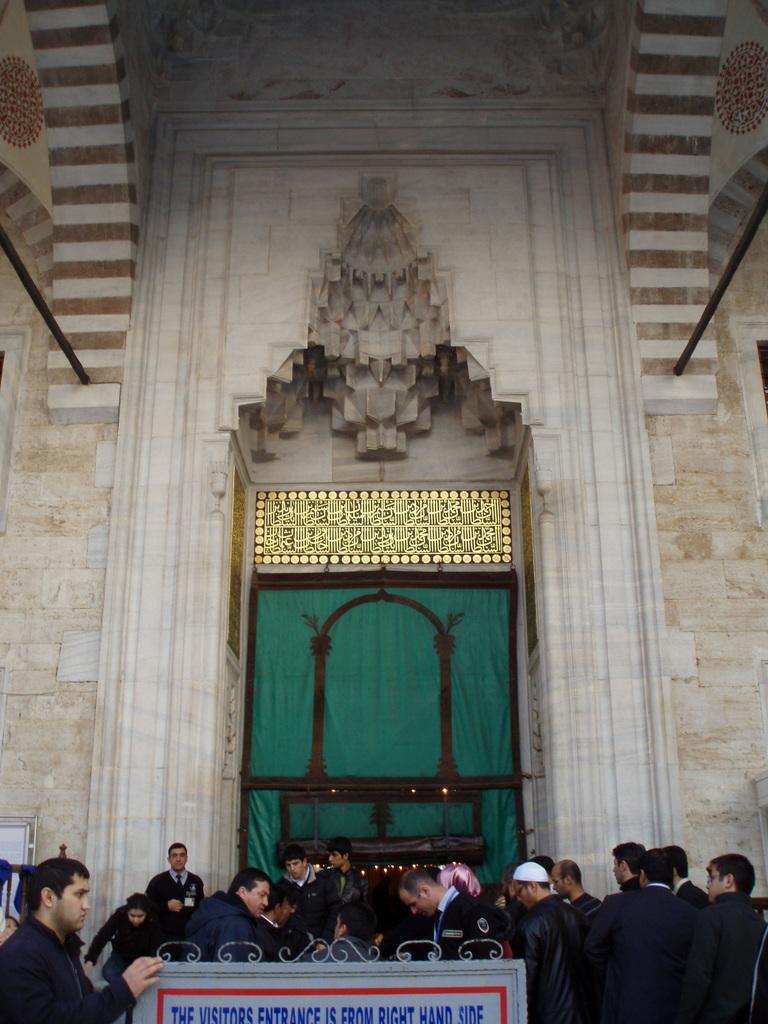How would you summarize this image in a sentence or two? In this image, we can see people wearing clothes. There is a board at the bottom of the image. In the background, we can see a wall. 